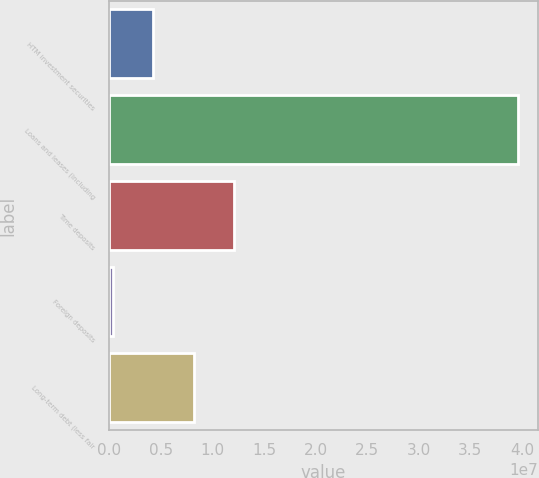Convert chart to OTSL. <chart><loc_0><loc_0><loc_500><loc_500><bar_chart><fcel>HTM investment securities<fcel>Loans and leases (including<fcel>Time deposits<fcel>Foreign deposits<fcel>Long-term debt (less fair<nl><fcel>4.25474e+06<fcel>3.95919e+07<fcel>1.21074e+07<fcel>328391<fcel>8.18108e+06<nl></chart> 